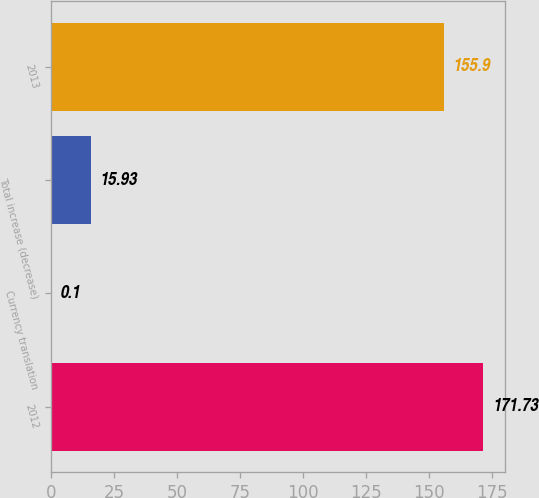Convert chart to OTSL. <chart><loc_0><loc_0><loc_500><loc_500><bar_chart><fcel>2012<fcel>Currency translation<fcel>Total increase (decrease)<fcel>2013<nl><fcel>171.73<fcel>0.1<fcel>15.93<fcel>155.9<nl></chart> 